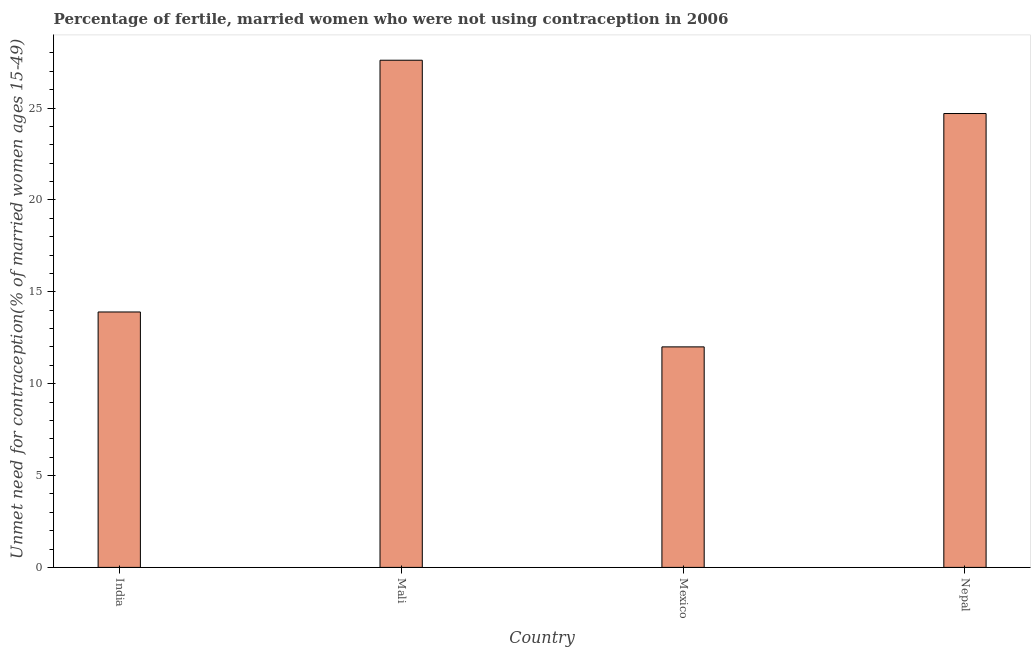Does the graph contain any zero values?
Offer a terse response. No. What is the title of the graph?
Provide a short and direct response. Percentage of fertile, married women who were not using contraception in 2006. What is the label or title of the X-axis?
Offer a terse response. Country. What is the label or title of the Y-axis?
Your answer should be compact.  Unmet need for contraception(% of married women ages 15-49). What is the number of married women who are not using contraception in Mali?
Your response must be concise. 27.6. Across all countries, what is the maximum number of married women who are not using contraception?
Ensure brevity in your answer.  27.6. In which country was the number of married women who are not using contraception maximum?
Provide a short and direct response. Mali. In which country was the number of married women who are not using contraception minimum?
Ensure brevity in your answer.  Mexico. What is the sum of the number of married women who are not using contraception?
Give a very brief answer. 78.2. What is the average number of married women who are not using contraception per country?
Ensure brevity in your answer.  19.55. What is the median number of married women who are not using contraception?
Ensure brevity in your answer.  19.3. What is the ratio of the number of married women who are not using contraception in Mexico to that in Nepal?
Provide a short and direct response. 0.49. Is the number of married women who are not using contraception in India less than that in Nepal?
Provide a short and direct response. Yes. Is the difference between the number of married women who are not using contraception in Mexico and Nepal greater than the difference between any two countries?
Make the answer very short. No. Is the sum of the number of married women who are not using contraception in India and Mexico greater than the maximum number of married women who are not using contraception across all countries?
Give a very brief answer. No. What is the difference between the highest and the lowest number of married women who are not using contraception?
Make the answer very short. 15.6. In how many countries, is the number of married women who are not using contraception greater than the average number of married women who are not using contraception taken over all countries?
Your response must be concise. 2. How many bars are there?
Offer a terse response. 4. Are the values on the major ticks of Y-axis written in scientific E-notation?
Your response must be concise. No. What is the  Unmet need for contraception(% of married women ages 15-49) in India?
Your response must be concise. 13.9. What is the  Unmet need for contraception(% of married women ages 15-49) in Mali?
Your answer should be very brief. 27.6. What is the  Unmet need for contraception(% of married women ages 15-49) of Mexico?
Your response must be concise. 12. What is the  Unmet need for contraception(% of married women ages 15-49) of Nepal?
Your answer should be very brief. 24.7. What is the difference between the  Unmet need for contraception(% of married women ages 15-49) in India and Mali?
Ensure brevity in your answer.  -13.7. What is the difference between the  Unmet need for contraception(% of married women ages 15-49) in India and Mexico?
Your response must be concise. 1.9. What is the difference between the  Unmet need for contraception(% of married women ages 15-49) in India and Nepal?
Your response must be concise. -10.8. What is the ratio of the  Unmet need for contraception(% of married women ages 15-49) in India to that in Mali?
Ensure brevity in your answer.  0.5. What is the ratio of the  Unmet need for contraception(% of married women ages 15-49) in India to that in Mexico?
Your answer should be compact. 1.16. What is the ratio of the  Unmet need for contraception(% of married women ages 15-49) in India to that in Nepal?
Provide a succinct answer. 0.56. What is the ratio of the  Unmet need for contraception(% of married women ages 15-49) in Mali to that in Mexico?
Offer a very short reply. 2.3. What is the ratio of the  Unmet need for contraception(% of married women ages 15-49) in Mali to that in Nepal?
Your response must be concise. 1.12. What is the ratio of the  Unmet need for contraception(% of married women ages 15-49) in Mexico to that in Nepal?
Your answer should be compact. 0.49. 